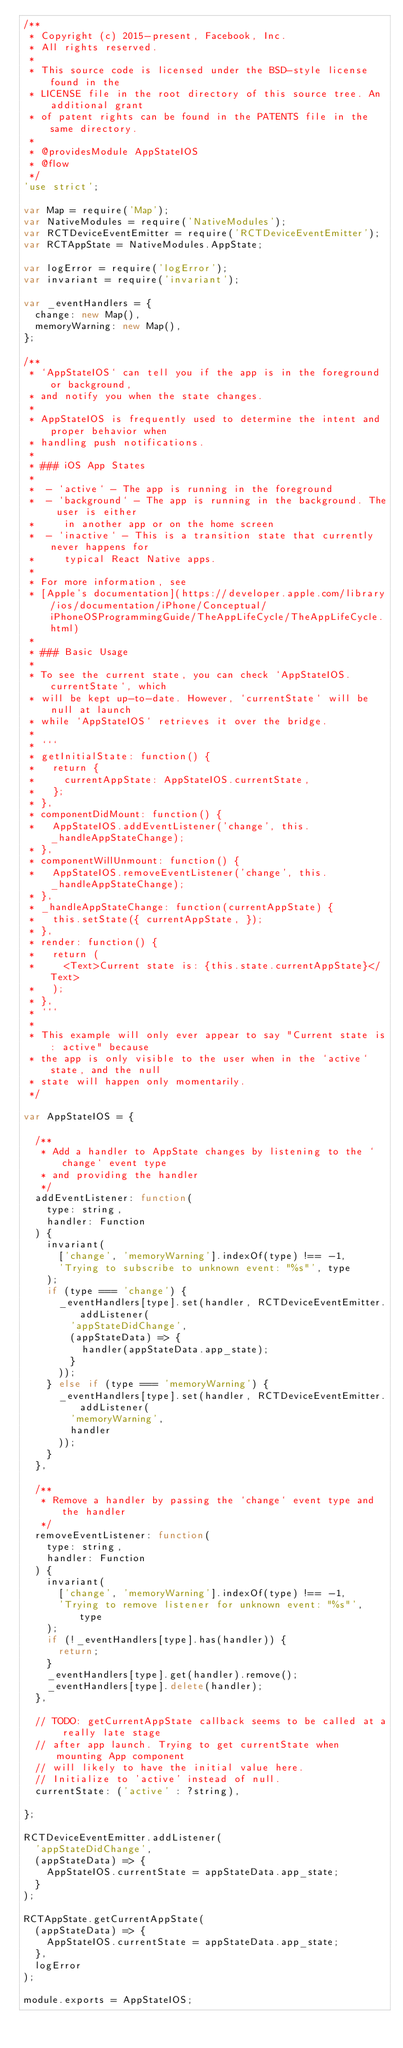Convert code to text. <code><loc_0><loc_0><loc_500><loc_500><_JavaScript_>/**
 * Copyright (c) 2015-present, Facebook, Inc.
 * All rights reserved.
 *
 * This source code is licensed under the BSD-style license found in the
 * LICENSE file in the root directory of this source tree. An additional grant
 * of patent rights can be found in the PATENTS file in the same directory.
 *
 * @providesModule AppStateIOS
 * @flow
 */
'use strict';

var Map = require('Map');
var NativeModules = require('NativeModules');
var RCTDeviceEventEmitter = require('RCTDeviceEventEmitter');
var RCTAppState = NativeModules.AppState;

var logError = require('logError');
var invariant = require('invariant');

var _eventHandlers = {
  change: new Map(),
  memoryWarning: new Map(),
};

/**
 * `AppStateIOS` can tell you if the app is in the foreground or background,
 * and notify you when the state changes.
 *
 * AppStateIOS is frequently used to determine the intent and proper behavior when
 * handling push notifications.
 *
 * ### iOS App States
 *
 *  - `active` - The app is running in the foreground
 *  - `background` - The app is running in the background. The user is either
 *     in another app or on the home screen
 *  - `inactive` - This is a transition state that currently never happens for
 *     typical React Native apps.
 *
 * For more information, see
 * [Apple's documentation](https://developer.apple.com/library/ios/documentation/iPhone/Conceptual/iPhoneOSProgrammingGuide/TheAppLifeCycle/TheAppLifeCycle.html)
 *
 * ### Basic Usage
 *
 * To see the current state, you can check `AppStateIOS.currentState`, which
 * will be kept up-to-date. However, `currentState` will be null at launch
 * while `AppStateIOS` retrieves it over the bridge.
 *
 * ```
 * getInitialState: function() {
 *   return {
 *     currentAppState: AppStateIOS.currentState,
 *   };
 * },
 * componentDidMount: function() {
 *   AppStateIOS.addEventListener('change', this._handleAppStateChange);
 * },
 * componentWillUnmount: function() {
 *   AppStateIOS.removeEventListener('change', this._handleAppStateChange);
 * },
 * _handleAppStateChange: function(currentAppState) {
 *   this.setState({ currentAppState, });
 * },
 * render: function() {
 *   return (
 *     <Text>Current state is: {this.state.currentAppState}</Text>
 *   );
 * },
 * ```
 *
 * This example will only ever appear to say "Current state is: active" because
 * the app is only visible to the user when in the `active` state, and the null
 * state will happen only momentarily.
 */

var AppStateIOS = {

  /**
   * Add a handler to AppState changes by listening to the `change` event type
   * and providing the handler
   */
  addEventListener: function(
    type: string,
    handler: Function
  ) {
    invariant(
      ['change', 'memoryWarning'].indexOf(type) !== -1,
      'Trying to subscribe to unknown event: "%s"', type
    );
    if (type === 'change') {
      _eventHandlers[type].set(handler, RCTDeviceEventEmitter.addListener(
        'appStateDidChange',
        (appStateData) => {
          handler(appStateData.app_state);
        }
      ));
    } else if (type === 'memoryWarning') {
      _eventHandlers[type].set(handler, RCTDeviceEventEmitter.addListener(
        'memoryWarning',
        handler
      ));
    }
  },

  /**
   * Remove a handler by passing the `change` event type and the handler
   */
  removeEventListener: function(
    type: string,
    handler: Function
  ) {
    invariant(
      ['change', 'memoryWarning'].indexOf(type) !== -1,
      'Trying to remove listener for unknown event: "%s"', type
    );
    if (!_eventHandlers[type].has(handler)) {
      return;
    }
    _eventHandlers[type].get(handler).remove();
    _eventHandlers[type].delete(handler);
  },

  // TODO: getCurrentAppState callback seems to be called at a really late stage
  // after app launch. Trying to get currentState when mounting App component
  // will likely to have the initial value here.
  // Initialize to 'active' instead of null.
  currentState: ('active' : ?string),

};

RCTDeviceEventEmitter.addListener(
  'appStateDidChange',
  (appStateData) => {
    AppStateIOS.currentState = appStateData.app_state;
  }
);

RCTAppState.getCurrentAppState(
  (appStateData) => {
    AppStateIOS.currentState = appStateData.app_state;
  },
  logError
);

module.exports = AppStateIOS;
</code> 